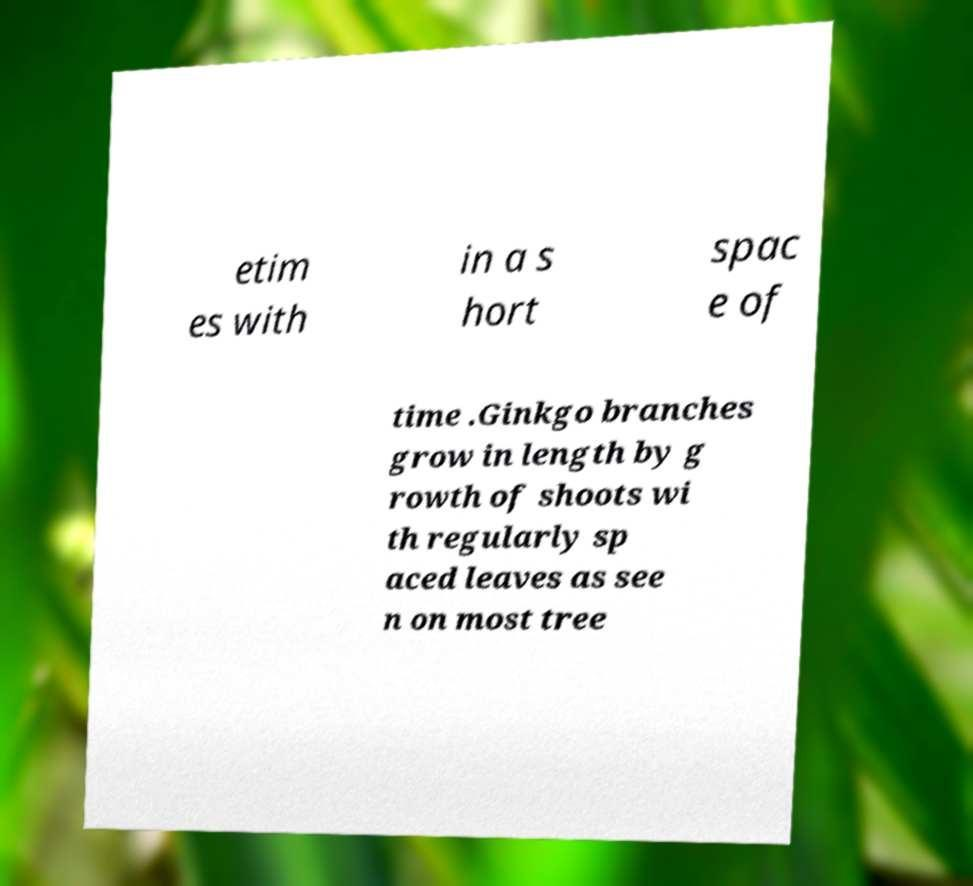What messages or text are displayed in this image? I need them in a readable, typed format. etim es with in a s hort spac e of time .Ginkgo branches grow in length by g rowth of shoots wi th regularly sp aced leaves as see n on most tree 